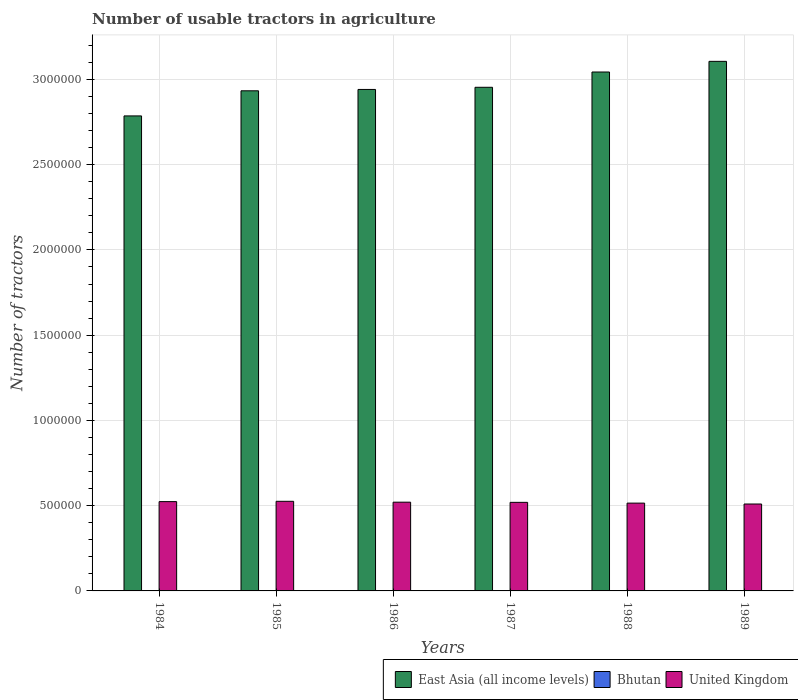How many different coloured bars are there?
Keep it short and to the point. 3. How many groups of bars are there?
Keep it short and to the point. 6. Are the number of bars on each tick of the X-axis equal?
Your response must be concise. Yes. How many bars are there on the 6th tick from the left?
Give a very brief answer. 3. How many bars are there on the 2nd tick from the right?
Keep it short and to the point. 3. What is the label of the 1st group of bars from the left?
Provide a succinct answer. 1984. In how many cases, is the number of bars for a given year not equal to the number of legend labels?
Give a very brief answer. 0. What is the number of usable tractors in agriculture in United Kingdom in 1987?
Your response must be concise. 5.19e+05. Across all years, what is the maximum number of usable tractors in agriculture in United Kingdom?
Provide a short and direct response. 5.26e+05. In which year was the number of usable tractors in agriculture in East Asia (all income levels) maximum?
Keep it short and to the point. 1989. In which year was the number of usable tractors in agriculture in United Kingdom minimum?
Your answer should be compact. 1989. What is the total number of usable tractors in agriculture in United Kingdom in the graph?
Your answer should be very brief. 3.11e+06. What is the difference between the number of usable tractors in agriculture in United Kingdom in 1985 and that in 1987?
Keep it short and to the point. 6054. What is the difference between the number of usable tractors in agriculture in Bhutan in 1988 and the number of usable tractors in agriculture in East Asia (all income levels) in 1984?
Your answer should be compact. -2.79e+06. What is the average number of usable tractors in agriculture in Bhutan per year?
Ensure brevity in your answer.  24.17. In the year 1986, what is the difference between the number of usable tractors in agriculture in United Kingdom and number of usable tractors in agriculture in Bhutan?
Keep it short and to the point. 5.20e+05. What is the ratio of the number of usable tractors in agriculture in East Asia (all income levels) in 1984 to that in 1988?
Your response must be concise. 0.92. What is the difference between the highest and the second highest number of usable tractors in agriculture in Bhutan?
Offer a very short reply. 10. What is the difference between the highest and the lowest number of usable tractors in agriculture in United Kingdom?
Make the answer very short. 1.58e+04. Is the sum of the number of usable tractors in agriculture in East Asia (all income levels) in 1985 and 1987 greater than the maximum number of usable tractors in agriculture in United Kingdom across all years?
Keep it short and to the point. Yes. What does the 1st bar from the left in 1986 represents?
Offer a terse response. East Asia (all income levels). What does the 1st bar from the right in 1989 represents?
Provide a short and direct response. United Kingdom. Is it the case that in every year, the sum of the number of usable tractors in agriculture in East Asia (all income levels) and number of usable tractors in agriculture in United Kingdom is greater than the number of usable tractors in agriculture in Bhutan?
Ensure brevity in your answer.  Yes. How many bars are there?
Your answer should be very brief. 18. Are all the bars in the graph horizontal?
Your answer should be very brief. No. How many years are there in the graph?
Ensure brevity in your answer.  6. What is the difference between two consecutive major ticks on the Y-axis?
Offer a very short reply. 5.00e+05. Are the values on the major ticks of Y-axis written in scientific E-notation?
Your response must be concise. No. Does the graph contain grids?
Offer a very short reply. Yes. Where does the legend appear in the graph?
Offer a very short reply. Bottom right. How many legend labels are there?
Your response must be concise. 3. How are the legend labels stacked?
Your response must be concise. Horizontal. What is the title of the graph?
Provide a succinct answer. Number of usable tractors in agriculture. Does "Zambia" appear as one of the legend labels in the graph?
Provide a short and direct response. No. What is the label or title of the Y-axis?
Ensure brevity in your answer.  Number of tractors. What is the Number of tractors of East Asia (all income levels) in 1984?
Your answer should be very brief. 2.79e+06. What is the Number of tractors in Bhutan in 1984?
Provide a short and direct response. 10. What is the Number of tractors in United Kingdom in 1984?
Your answer should be compact. 5.24e+05. What is the Number of tractors of East Asia (all income levels) in 1985?
Offer a terse response. 2.93e+06. What is the Number of tractors in United Kingdom in 1985?
Provide a succinct answer. 5.26e+05. What is the Number of tractors in East Asia (all income levels) in 1986?
Ensure brevity in your answer.  2.94e+06. What is the Number of tractors of United Kingdom in 1986?
Offer a very short reply. 5.20e+05. What is the Number of tractors in East Asia (all income levels) in 1987?
Your response must be concise. 2.95e+06. What is the Number of tractors in Bhutan in 1987?
Ensure brevity in your answer.  30. What is the Number of tractors in United Kingdom in 1987?
Your response must be concise. 5.19e+05. What is the Number of tractors in East Asia (all income levels) in 1988?
Your answer should be compact. 3.04e+06. What is the Number of tractors of Bhutan in 1988?
Provide a succinct answer. 30. What is the Number of tractors of United Kingdom in 1988?
Your answer should be compact. 5.15e+05. What is the Number of tractors of East Asia (all income levels) in 1989?
Make the answer very short. 3.11e+06. What is the Number of tractors in United Kingdom in 1989?
Provide a short and direct response. 5.10e+05. Across all years, what is the maximum Number of tractors of East Asia (all income levels)?
Your answer should be very brief. 3.11e+06. Across all years, what is the maximum Number of tractors of United Kingdom?
Your answer should be very brief. 5.26e+05. Across all years, what is the minimum Number of tractors in East Asia (all income levels)?
Provide a short and direct response. 2.79e+06. Across all years, what is the minimum Number of tractors of Bhutan?
Your response must be concise. 10. Across all years, what is the minimum Number of tractors of United Kingdom?
Your answer should be very brief. 5.10e+05. What is the total Number of tractors in East Asia (all income levels) in the graph?
Keep it short and to the point. 1.78e+07. What is the total Number of tractors in Bhutan in the graph?
Offer a very short reply. 145. What is the total Number of tractors of United Kingdom in the graph?
Your answer should be very brief. 3.11e+06. What is the difference between the Number of tractors of East Asia (all income levels) in 1984 and that in 1985?
Your answer should be compact. -1.47e+05. What is the difference between the Number of tractors in Bhutan in 1984 and that in 1985?
Give a very brief answer. -5. What is the difference between the Number of tractors of United Kingdom in 1984 and that in 1985?
Offer a terse response. -1809. What is the difference between the Number of tractors in East Asia (all income levels) in 1984 and that in 1986?
Offer a very short reply. -1.55e+05. What is the difference between the Number of tractors of United Kingdom in 1984 and that in 1986?
Give a very brief answer. 3245. What is the difference between the Number of tractors of East Asia (all income levels) in 1984 and that in 1987?
Offer a very short reply. -1.68e+05. What is the difference between the Number of tractors of United Kingdom in 1984 and that in 1987?
Provide a succinct answer. 4245. What is the difference between the Number of tractors of East Asia (all income levels) in 1984 and that in 1988?
Give a very brief answer. -2.57e+05. What is the difference between the Number of tractors in United Kingdom in 1984 and that in 1988?
Keep it short and to the point. 8740. What is the difference between the Number of tractors of East Asia (all income levels) in 1984 and that in 1989?
Keep it short and to the point. -3.20e+05. What is the difference between the Number of tractors in Bhutan in 1984 and that in 1989?
Give a very brief answer. -30. What is the difference between the Number of tractors in United Kingdom in 1984 and that in 1989?
Make the answer very short. 1.40e+04. What is the difference between the Number of tractors in East Asia (all income levels) in 1985 and that in 1986?
Provide a succinct answer. -8015. What is the difference between the Number of tractors in United Kingdom in 1985 and that in 1986?
Offer a terse response. 5054. What is the difference between the Number of tractors of East Asia (all income levels) in 1985 and that in 1987?
Give a very brief answer. -2.06e+04. What is the difference between the Number of tractors in United Kingdom in 1985 and that in 1987?
Offer a terse response. 6054. What is the difference between the Number of tractors in East Asia (all income levels) in 1985 and that in 1988?
Ensure brevity in your answer.  -1.10e+05. What is the difference between the Number of tractors in Bhutan in 1985 and that in 1988?
Provide a succinct answer. -15. What is the difference between the Number of tractors in United Kingdom in 1985 and that in 1988?
Your answer should be very brief. 1.05e+04. What is the difference between the Number of tractors in East Asia (all income levels) in 1985 and that in 1989?
Your response must be concise. -1.73e+05. What is the difference between the Number of tractors of United Kingdom in 1985 and that in 1989?
Your answer should be compact. 1.58e+04. What is the difference between the Number of tractors in East Asia (all income levels) in 1986 and that in 1987?
Offer a very short reply. -1.26e+04. What is the difference between the Number of tractors in Bhutan in 1986 and that in 1987?
Make the answer very short. -10. What is the difference between the Number of tractors in East Asia (all income levels) in 1986 and that in 1988?
Ensure brevity in your answer.  -1.02e+05. What is the difference between the Number of tractors in United Kingdom in 1986 and that in 1988?
Offer a very short reply. 5495. What is the difference between the Number of tractors in East Asia (all income levels) in 1986 and that in 1989?
Provide a succinct answer. -1.65e+05. What is the difference between the Number of tractors in United Kingdom in 1986 and that in 1989?
Ensure brevity in your answer.  1.07e+04. What is the difference between the Number of tractors in East Asia (all income levels) in 1987 and that in 1988?
Provide a succinct answer. -8.96e+04. What is the difference between the Number of tractors in Bhutan in 1987 and that in 1988?
Offer a terse response. 0. What is the difference between the Number of tractors of United Kingdom in 1987 and that in 1988?
Give a very brief answer. 4495. What is the difference between the Number of tractors of East Asia (all income levels) in 1987 and that in 1989?
Give a very brief answer. -1.52e+05. What is the difference between the Number of tractors of United Kingdom in 1987 and that in 1989?
Offer a terse response. 9715. What is the difference between the Number of tractors of East Asia (all income levels) in 1988 and that in 1989?
Your answer should be compact. -6.25e+04. What is the difference between the Number of tractors in Bhutan in 1988 and that in 1989?
Offer a very short reply. -10. What is the difference between the Number of tractors of United Kingdom in 1988 and that in 1989?
Your response must be concise. 5220. What is the difference between the Number of tractors of East Asia (all income levels) in 1984 and the Number of tractors of Bhutan in 1985?
Give a very brief answer. 2.79e+06. What is the difference between the Number of tractors of East Asia (all income levels) in 1984 and the Number of tractors of United Kingdom in 1985?
Ensure brevity in your answer.  2.26e+06. What is the difference between the Number of tractors in Bhutan in 1984 and the Number of tractors in United Kingdom in 1985?
Your answer should be very brief. -5.26e+05. What is the difference between the Number of tractors of East Asia (all income levels) in 1984 and the Number of tractors of Bhutan in 1986?
Give a very brief answer. 2.79e+06. What is the difference between the Number of tractors in East Asia (all income levels) in 1984 and the Number of tractors in United Kingdom in 1986?
Provide a succinct answer. 2.27e+06. What is the difference between the Number of tractors of Bhutan in 1984 and the Number of tractors of United Kingdom in 1986?
Your answer should be compact. -5.20e+05. What is the difference between the Number of tractors in East Asia (all income levels) in 1984 and the Number of tractors in Bhutan in 1987?
Provide a succinct answer. 2.79e+06. What is the difference between the Number of tractors of East Asia (all income levels) in 1984 and the Number of tractors of United Kingdom in 1987?
Your answer should be very brief. 2.27e+06. What is the difference between the Number of tractors in Bhutan in 1984 and the Number of tractors in United Kingdom in 1987?
Ensure brevity in your answer.  -5.19e+05. What is the difference between the Number of tractors of East Asia (all income levels) in 1984 and the Number of tractors of Bhutan in 1988?
Your answer should be very brief. 2.79e+06. What is the difference between the Number of tractors of East Asia (all income levels) in 1984 and the Number of tractors of United Kingdom in 1988?
Offer a very short reply. 2.27e+06. What is the difference between the Number of tractors of Bhutan in 1984 and the Number of tractors of United Kingdom in 1988?
Your response must be concise. -5.15e+05. What is the difference between the Number of tractors of East Asia (all income levels) in 1984 and the Number of tractors of Bhutan in 1989?
Your response must be concise. 2.79e+06. What is the difference between the Number of tractors in East Asia (all income levels) in 1984 and the Number of tractors in United Kingdom in 1989?
Ensure brevity in your answer.  2.28e+06. What is the difference between the Number of tractors of Bhutan in 1984 and the Number of tractors of United Kingdom in 1989?
Make the answer very short. -5.10e+05. What is the difference between the Number of tractors of East Asia (all income levels) in 1985 and the Number of tractors of Bhutan in 1986?
Your answer should be very brief. 2.93e+06. What is the difference between the Number of tractors of East Asia (all income levels) in 1985 and the Number of tractors of United Kingdom in 1986?
Keep it short and to the point. 2.41e+06. What is the difference between the Number of tractors in Bhutan in 1985 and the Number of tractors in United Kingdom in 1986?
Your answer should be very brief. -5.20e+05. What is the difference between the Number of tractors in East Asia (all income levels) in 1985 and the Number of tractors in Bhutan in 1987?
Ensure brevity in your answer.  2.93e+06. What is the difference between the Number of tractors in East Asia (all income levels) in 1985 and the Number of tractors in United Kingdom in 1987?
Keep it short and to the point. 2.41e+06. What is the difference between the Number of tractors in Bhutan in 1985 and the Number of tractors in United Kingdom in 1987?
Give a very brief answer. -5.19e+05. What is the difference between the Number of tractors in East Asia (all income levels) in 1985 and the Number of tractors in Bhutan in 1988?
Offer a very short reply. 2.93e+06. What is the difference between the Number of tractors of East Asia (all income levels) in 1985 and the Number of tractors of United Kingdom in 1988?
Offer a very short reply. 2.42e+06. What is the difference between the Number of tractors of Bhutan in 1985 and the Number of tractors of United Kingdom in 1988?
Provide a short and direct response. -5.15e+05. What is the difference between the Number of tractors in East Asia (all income levels) in 1985 and the Number of tractors in Bhutan in 1989?
Your answer should be compact. 2.93e+06. What is the difference between the Number of tractors of East Asia (all income levels) in 1985 and the Number of tractors of United Kingdom in 1989?
Keep it short and to the point. 2.42e+06. What is the difference between the Number of tractors of Bhutan in 1985 and the Number of tractors of United Kingdom in 1989?
Offer a very short reply. -5.10e+05. What is the difference between the Number of tractors of East Asia (all income levels) in 1986 and the Number of tractors of Bhutan in 1987?
Your response must be concise. 2.94e+06. What is the difference between the Number of tractors in East Asia (all income levels) in 1986 and the Number of tractors in United Kingdom in 1987?
Your response must be concise. 2.42e+06. What is the difference between the Number of tractors in Bhutan in 1986 and the Number of tractors in United Kingdom in 1987?
Your response must be concise. -5.19e+05. What is the difference between the Number of tractors in East Asia (all income levels) in 1986 and the Number of tractors in Bhutan in 1988?
Provide a short and direct response. 2.94e+06. What is the difference between the Number of tractors of East Asia (all income levels) in 1986 and the Number of tractors of United Kingdom in 1988?
Ensure brevity in your answer.  2.43e+06. What is the difference between the Number of tractors of Bhutan in 1986 and the Number of tractors of United Kingdom in 1988?
Offer a very short reply. -5.15e+05. What is the difference between the Number of tractors of East Asia (all income levels) in 1986 and the Number of tractors of Bhutan in 1989?
Ensure brevity in your answer.  2.94e+06. What is the difference between the Number of tractors of East Asia (all income levels) in 1986 and the Number of tractors of United Kingdom in 1989?
Offer a very short reply. 2.43e+06. What is the difference between the Number of tractors in Bhutan in 1986 and the Number of tractors in United Kingdom in 1989?
Provide a succinct answer. -5.10e+05. What is the difference between the Number of tractors of East Asia (all income levels) in 1987 and the Number of tractors of Bhutan in 1988?
Give a very brief answer. 2.95e+06. What is the difference between the Number of tractors in East Asia (all income levels) in 1987 and the Number of tractors in United Kingdom in 1988?
Provide a succinct answer. 2.44e+06. What is the difference between the Number of tractors of Bhutan in 1987 and the Number of tractors of United Kingdom in 1988?
Make the answer very short. -5.15e+05. What is the difference between the Number of tractors of East Asia (all income levels) in 1987 and the Number of tractors of Bhutan in 1989?
Give a very brief answer. 2.95e+06. What is the difference between the Number of tractors in East Asia (all income levels) in 1987 and the Number of tractors in United Kingdom in 1989?
Your answer should be very brief. 2.44e+06. What is the difference between the Number of tractors of Bhutan in 1987 and the Number of tractors of United Kingdom in 1989?
Offer a terse response. -5.10e+05. What is the difference between the Number of tractors in East Asia (all income levels) in 1988 and the Number of tractors in Bhutan in 1989?
Provide a succinct answer. 3.04e+06. What is the difference between the Number of tractors of East Asia (all income levels) in 1988 and the Number of tractors of United Kingdom in 1989?
Ensure brevity in your answer.  2.53e+06. What is the difference between the Number of tractors in Bhutan in 1988 and the Number of tractors in United Kingdom in 1989?
Provide a short and direct response. -5.10e+05. What is the average Number of tractors of East Asia (all income levels) per year?
Your answer should be compact. 2.96e+06. What is the average Number of tractors in Bhutan per year?
Ensure brevity in your answer.  24.17. What is the average Number of tractors in United Kingdom per year?
Your answer should be compact. 5.19e+05. In the year 1984, what is the difference between the Number of tractors in East Asia (all income levels) and Number of tractors in Bhutan?
Make the answer very short. 2.79e+06. In the year 1984, what is the difference between the Number of tractors of East Asia (all income levels) and Number of tractors of United Kingdom?
Your answer should be compact. 2.26e+06. In the year 1984, what is the difference between the Number of tractors of Bhutan and Number of tractors of United Kingdom?
Give a very brief answer. -5.24e+05. In the year 1985, what is the difference between the Number of tractors of East Asia (all income levels) and Number of tractors of Bhutan?
Offer a very short reply. 2.93e+06. In the year 1985, what is the difference between the Number of tractors in East Asia (all income levels) and Number of tractors in United Kingdom?
Provide a succinct answer. 2.41e+06. In the year 1985, what is the difference between the Number of tractors in Bhutan and Number of tractors in United Kingdom?
Offer a terse response. -5.26e+05. In the year 1986, what is the difference between the Number of tractors in East Asia (all income levels) and Number of tractors in Bhutan?
Make the answer very short. 2.94e+06. In the year 1986, what is the difference between the Number of tractors of East Asia (all income levels) and Number of tractors of United Kingdom?
Offer a terse response. 2.42e+06. In the year 1986, what is the difference between the Number of tractors of Bhutan and Number of tractors of United Kingdom?
Give a very brief answer. -5.20e+05. In the year 1987, what is the difference between the Number of tractors in East Asia (all income levels) and Number of tractors in Bhutan?
Give a very brief answer. 2.95e+06. In the year 1987, what is the difference between the Number of tractors in East Asia (all income levels) and Number of tractors in United Kingdom?
Make the answer very short. 2.43e+06. In the year 1987, what is the difference between the Number of tractors of Bhutan and Number of tractors of United Kingdom?
Ensure brevity in your answer.  -5.19e+05. In the year 1988, what is the difference between the Number of tractors of East Asia (all income levels) and Number of tractors of Bhutan?
Keep it short and to the point. 3.04e+06. In the year 1988, what is the difference between the Number of tractors in East Asia (all income levels) and Number of tractors in United Kingdom?
Keep it short and to the point. 2.53e+06. In the year 1988, what is the difference between the Number of tractors of Bhutan and Number of tractors of United Kingdom?
Your response must be concise. -5.15e+05. In the year 1989, what is the difference between the Number of tractors of East Asia (all income levels) and Number of tractors of Bhutan?
Your answer should be compact. 3.11e+06. In the year 1989, what is the difference between the Number of tractors of East Asia (all income levels) and Number of tractors of United Kingdom?
Provide a short and direct response. 2.60e+06. In the year 1989, what is the difference between the Number of tractors in Bhutan and Number of tractors in United Kingdom?
Keep it short and to the point. -5.10e+05. What is the ratio of the Number of tractors of East Asia (all income levels) in 1984 to that in 1985?
Keep it short and to the point. 0.95. What is the ratio of the Number of tractors in East Asia (all income levels) in 1984 to that in 1986?
Your answer should be very brief. 0.95. What is the ratio of the Number of tractors in United Kingdom in 1984 to that in 1986?
Provide a short and direct response. 1.01. What is the ratio of the Number of tractors in East Asia (all income levels) in 1984 to that in 1987?
Make the answer very short. 0.94. What is the ratio of the Number of tractors in United Kingdom in 1984 to that in 1987?
Offer a very short reply. 1.01. What is the ratio of the Number of tractors of East Asia (all income levels) in 1984 to that in 1988?
Your answer should be very brief. 0.92. What is the ratio of the Number of tractors in East Asia (all income levels) in 1984 to that in 1989?
Ensure brevity in your answer.  0.9. What is the ratio of the Number of tractors in Bhutan in 1984 to that in 1989?
Provide a short and direct response. 0.25. What is the ratio of the Number of tractors of United Kingdom in 1984 to that in 1989?
Your answer should be very brief. 1.03. What is the ratio of the Number of tractors of East Asia (all income levels) in 1985 to that in 1986?
Ensure brevity in your answer.  1. What is the ratio of the Number of tractors of United Kingdom in 1985 to that in 1986?
Your response must be concise. 1.01. What is the ratio of the Number of tractors of East Asia (all income levels) in 1985 to that in 1987?
Your response must be concise. 0.99. What is the ratio of the Number of tractors in United Kingdom in 1985 to that in 1987?
Provide a short and direct response. 1.01. What is the ratio of the Number of tractors of East Asia (all income levels) in 1985 to that in 1988?
Give a very brief answer. 0.96. What is the ratio of the Number of tractors of Bhutan in 1985 to that in 1988?
Provide a short and direct response. 0.5. What is the ratio of the Number of tractors of United Kingdom in 1985 to that in 1988?
Your answer should be compact. 1.02. What is the ratio of the Number of tractors of Bhutan in 1985 to that in 1989?
Offer a terse response. 0.38. What is the ratio of the Number of tractors in United Kingdom in 1985 to that in 1989?
Ensure brevity in your answer.  1.03. What is the ratio of the Number of tractors in United Kingdom in 1986 to that in 1987?
Your answer should be compact. 1. What is the ratio of the Number of tractors of East Asia (all income levels) in 1986 to that in 1988?
Your answer should be very brief. 0.97. What is the ratio of the Number of tractors of United Kingdom in 1986 to that in 1988?
Your response must be concise. 1.01. What is the ratio of the Number of tractors of East Asia (all income levels) in 1986 to that in 1989?
Your answer should be very brief. 0.95. What is the ratio of the Number of tractors in East Asia (all income levels) in 1987 to that in 1988?
Give a very brief answer. 0.97. What is the ratio of the Number of tractors of United Kingdom in 1987 to that in 1988?
Make the answer very short. 1.01. What is the ratio of the Number of tractors of East Asia (all income levels) in 1987 to that in 1989?
Provide a short and direct response. 0.95. What is the ratio of the Number of tractors of Bhutan in 1987 to that in 1989?
Give a very brief answer. 0.75. What is the ratio of the Number of tractors of United Kingdom in 1987 to that in 1989?
Offer a terse response. 1.02. What is the ratio of the Number of tractors of East Asia (all income levels) in 1988 to that in 1989?
Provide a succinct answer. 0.98. What is the ratio of the Number of tractors of Bhutan in 1988 to that in 1989?
Your answer should be very brief. 0.75. What is the ratio of the Number of tractors of United Kingdom in 1988 to that in 1989?
Keep it short and to the point. 1.01. What is the difference between the highest and the second highest Number of tractors in East Asia (all income levels)?
Ensure brevity in your answer.  6.25e+04. What is the difference between the highest and the second highest Number of tractors in United Kingdom?
Make the answer very short. 1809. What is the difference between the highest and the lowest Number of tractors in East Asia (all income levels)?
Your answer should be compact. 3.20e+05. What is the difference between the highest and the lowest Number of tractors in Bhutan?
Your response must be concise. 30. What is the difference between the highest and the lowest Number of tractors of United Kingdom?
Offer a terse response. 1.58e+04. 